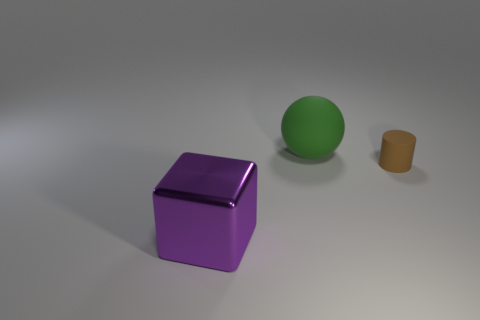Is there anything else that is the same material as the large purple object?
Ensure brevity in your answer.  No. Are there any metallic cubes that are to the right of the matte thing that is in front of the big thing that is behind the big purple cube?
Keep it short and to the point. No. What is the material of the large thing behind the big metal thing?
Offer a very short reply. Rubber. How many large objects are brown cylinders or purple metal cubes?
Provide a succinct answer. 1. Does the matte object that is in front of the green matte ball have the same size as the big matte sphere?
Give a very brief answer. No. How many other things are the same color as the rubber ball?
Offer a very short reply. 0. What is the material of the brown thing?
Your response must be concise. Rubber. The object that is both in front of the green object and right of the block is made of what material?
Offer a terse response. Rubber. What number of things are big purple metallic cubes that are in front of the large green matte thing or large matte balls?
Your response must be concise. 2. Is the color of the shiny thing the same as the tiny cylinder?
Keep it short and to the point. No. 